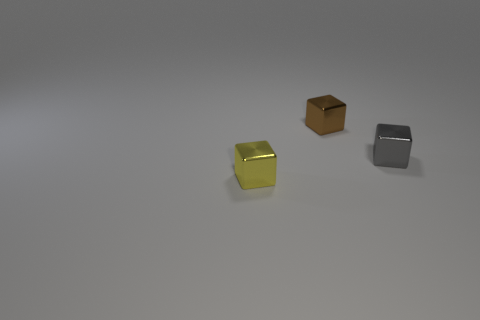Subtract all gray cubes. How many cubes are left? 2 Subtract 1 cubes. How many cubes are left? 2 Add 3 small rubber cylinders. How many objects exist? 6 Subtract 1 yellow cubes. How many objects are left? 2 Subtract all brown blocks. Subtract all cyan cylinders. How many blocks are left? 2 Subtract all green cylinders. How many gray cubes are left? 1 Subtract all big purple matte cubes. Subtract all shiny cubes. How many objects are left? 0 Add 3 small shiny objects. How many small shiny objects are left? 6 Add 1 brown objects. How many brown objects exist? 2 